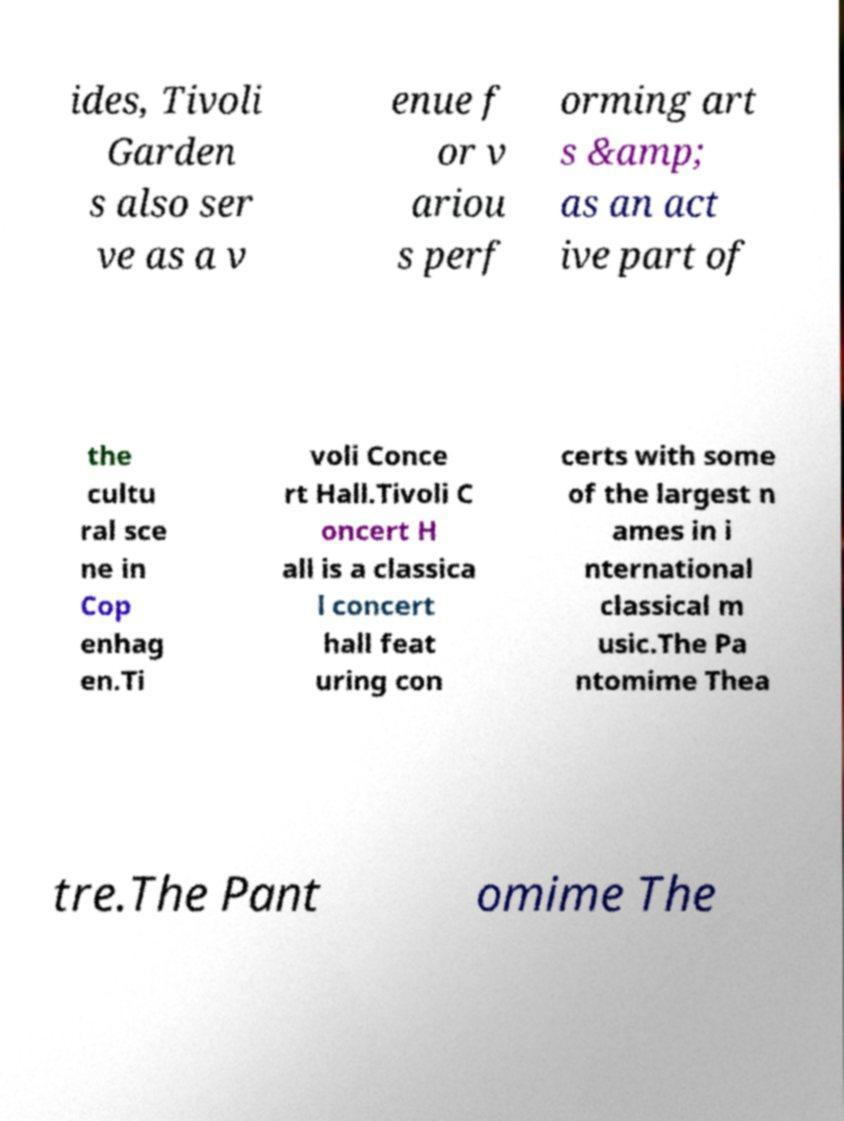Please identify and transcribe the text found in this image. ides, Tivoli Garden s also ser ve as a v enue f or v ariou s perf orming art s &amp; as an act ive part of the cultu ral sce ne in Cop enhag en.Ti voli Conce rt Hall.Tivoli C oncert H all is a classica l concert hall feat uring con certs with some of the largest n ames in i nternational classical m usic.The Pa ntomime Thea tre.The Pant omime The 